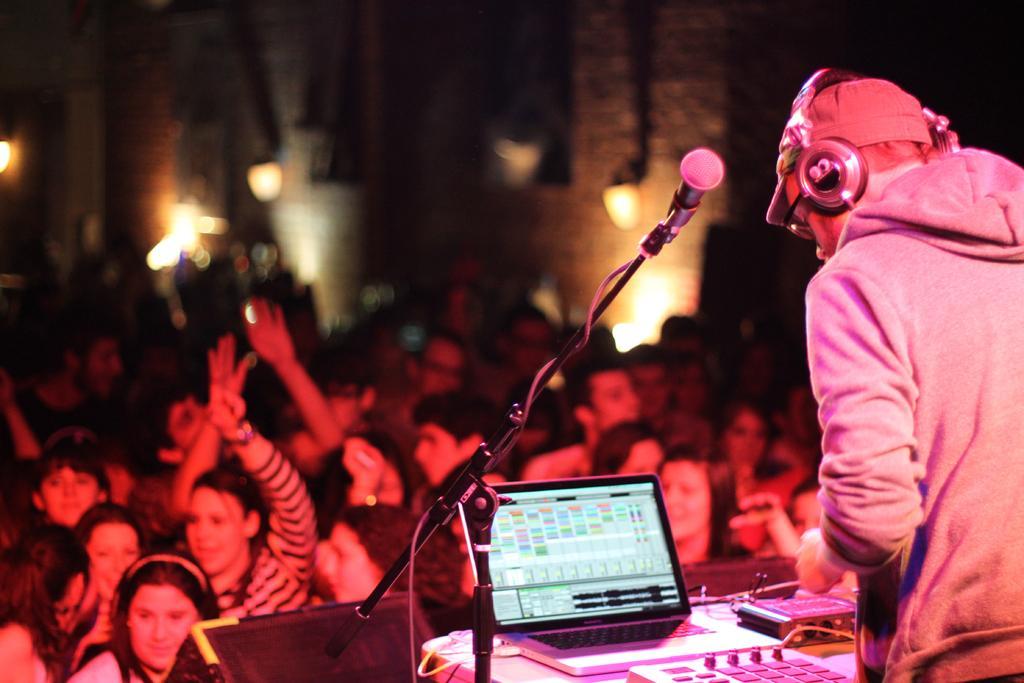In one or two sentences, can you explain what this image depicts? In this image we can see a person is standing. He is wearing hoodie and headsets. In front of him laptop, controller and mic is present. Background of the image so many people are standing and dancing. 